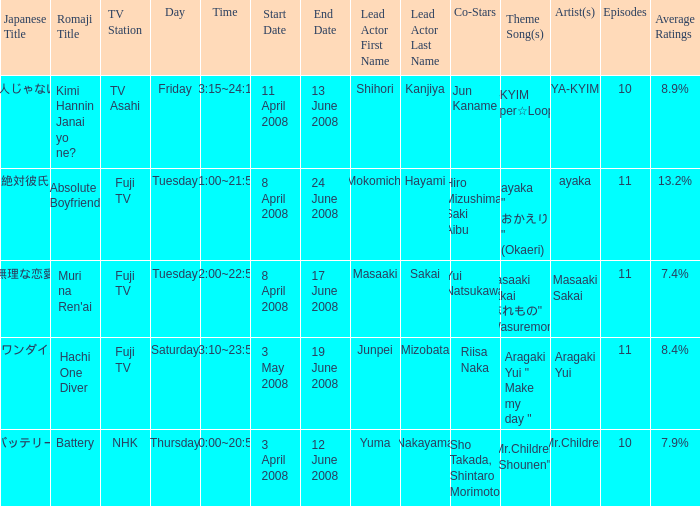Give me the full table as a dictionary. {'header': ['Japanese Title', 'Romaji Title', 'TV Station', 'Day', 'Time', 'Start Date', 'End Date', 'Lead Actor First Name', 'Lead Actor Last Name', 'Co-Stars', 'Theme Song(s)', 'Artist(s)', 'Episodes', 'Average Ratings'], 'rows': [['キミ犯人じゃないよね?', 'Kimi Hannin Janai yo ne?', 'TV Asahi', 'Friday', '23:15~24:10', '11 April 2008', '13 June 2008', 'Shihori', 'Kanjiya', 'Jun Kaname', 'YA-KYIM "Super☆Looper"', 'YA-KYIM', '10', '8.9%'], ['絶対彼氏', 'Absolute Boyfriend', 'Fuji TV', 'Tuesday', '21:00~21:54', '8 April 2008', '24 June 2008', 'Mokomichi', 'Hayami', 'Hiro Mizushima, Saki Aibu', 'ayaka " おかえり " (Okaeri)', 'ayaka', '11', '13.2%'], ['無理な恋愛', "Muri na Ren'ai", 'Fuji TV', 'Tuesday', '22:00~22:54', '8 April 2008', '17 June 2008', 'Masaaki', 'Sakai', 'Yui Natsukawa', 'Masaaki Sakai "忘れもの" (Wasuremono)', 'Masaaki Sakai', '11', '7.4%'], ['ハチワンダイバー', 'Hachi One Diver', 'Fuji TV', 'Saturday', '23:10~23:55', '3 May 2008', '19 June 2008', 'Junpei', 'Mizobata', 'Riisa Naka', 'Aragaki Yui " Make my day "', 'Aragaki Yui', '11', '8.4%'], ['バッテリー', 'Battery', 'NHK', 'Thursday', '20:00~20:54', '3 April 2008', '12 June 2008', 'Yuma', 'Nakayama', 'Sho Takada, Shintaro Morimoto', 'Mr.Children "Shounen"', 'Mr.Children', '10', '7.9%']]} What is the average rating for tv asahi? 8.9%. 